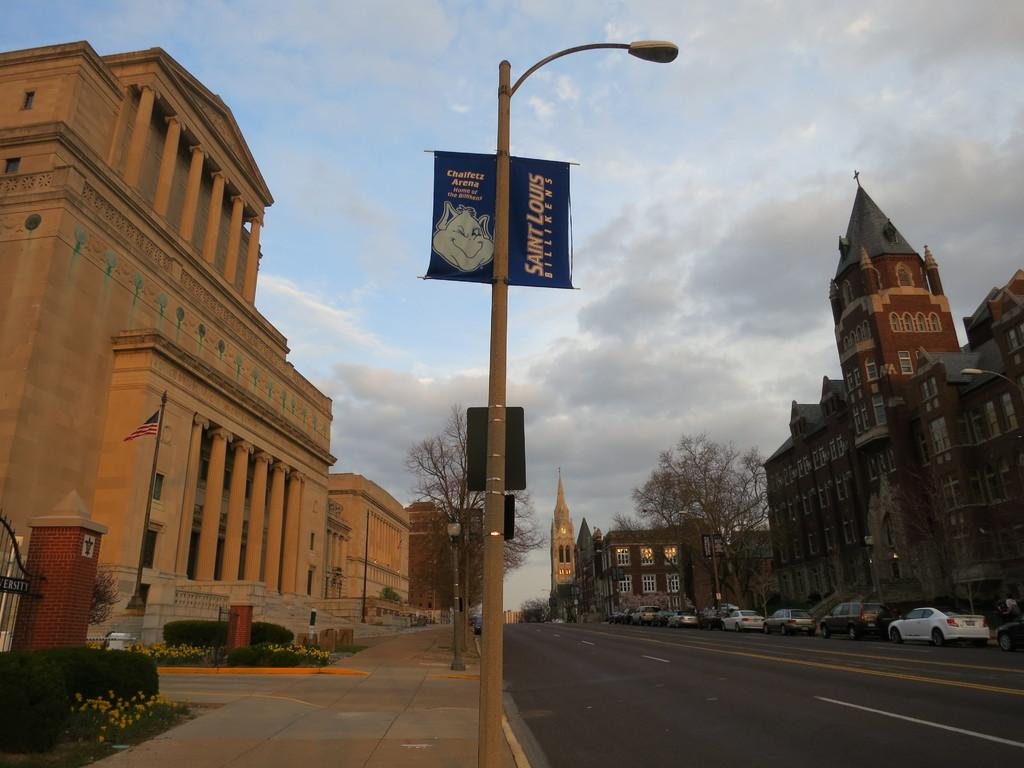What can be seen on the road in the image? There are vehicles on the road in the image. What type of structures are visible in the image? There are buildings in the image. What type of vegetation is present in the image? Plants and trees are visible in the image. What type of vertical structures are in the image? Poles are in the image. What type of illumination is present in the image? Lights are present in the image. What type of flat, sign-like objects are in the image? Boards are in the image. What can be seen in the background of the image? The sky is visible in the background of the image. What type of soup is being served in the image? There is no soup present in the image. What season is depicted in the image? The image does not depict a specific season; it only shows vehicles, buildings, plants, trees, poles, lights, boards, and the sky. 